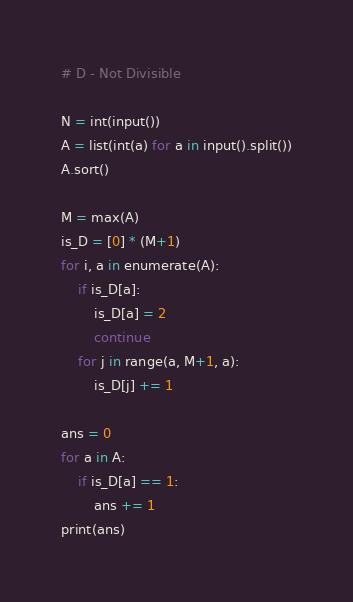<code> <loc_0><loc_0><loc_500><loc_500><_Python_># D - Not Divisible

N = int(input())
A = list(int(a) for a in input().split())
A.sort()

M = max(A)
is_D = [0] * (M+1)
for i, a in enumerate(A):
    if is_D[a]:
        is_D[a] = 2
        continue
    for j in range(a, M+1, a):
        is_D[j] += 1

ans = 0
for a in A:
    if is_D[a] == 1:
        ans += 1
print(ans)</code> 